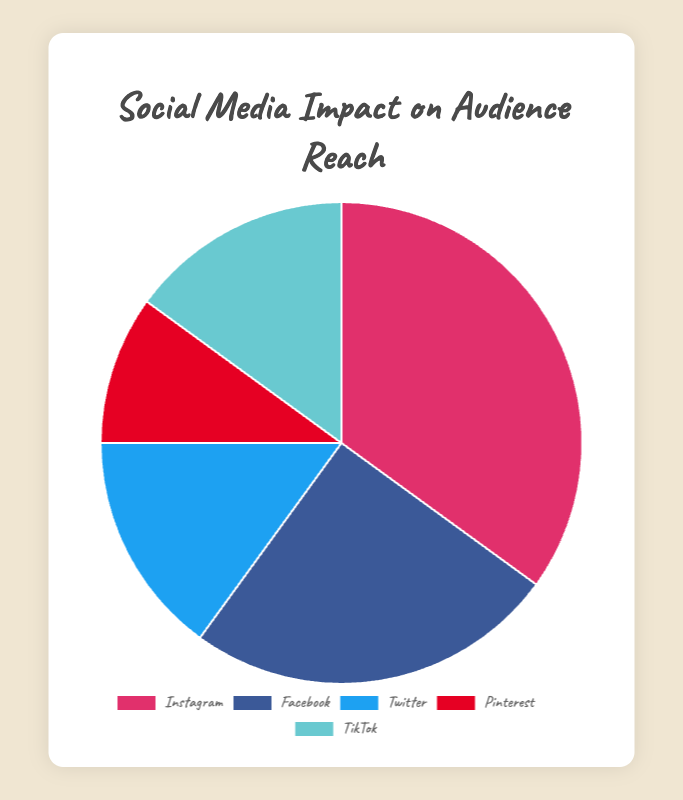What platform holds the largest audience reach percentage? Instagram holds the largest audience reach with 35%. This is clear from the pie chart where Instagram has the largest segment.
Answer: Instagram Which two platforms together account for 50% of the audience reach? Facebook and TikTok both contribute 25% (Facebook: 25%, TikTok: 15%) and 15% (15%) respectively. Adding these percentages (25% + 15%) results in exactly 50%.
Answer: Facebook and Twitter Which platform's segment is visually the smallest? Pinterest has the smallest segment of the pie chart, indicating its audience reach percentage is the lowest at 10%.
Answer: Pinterest How much larger is Instagram's audience reach compared to Pinterest's? Instagram's reach is 35% while Pinterest's reach is 10%. The difference can be calculated as 35% - 10% = 25%.
Answer: 25% If you combine Twitter and TikTok, what is their total audience reach percentage? Twitter has a 15% reach and TikTok also has a 15% reach. Adding these (15% + 15%) gives a total audience reach of 30%.
Answer: 30% What percentage of the total audience reach is covered by platforms other than Instagram? Instagram's reach is 35%, so the remaining percentage can be calculated by subtracting Instagram's percentage from 100%. Therefore, 100% - 35% = 65%.
Answer: 65% Which two platforms have equal audience reach percentages? Twitter and TikTok both have an audience reach of 15%. This is visually clear from the pie chart segments being equal in size and values indicated.
Answer: Twitter and TikTok What is the combined percentage of audience reach for platforms traditionally considered visual-centric (Instagram and Pinterest)? Instagram provides 35% and Pinterest provides 10%. Combining these, 35% + 10% = 45%.
Answer: 45% Considering all the platforms, what is the average audience reach percentage? The sum of all platforms' audience reach percentages is 100% (35 + 25 + 15 + 10 + 15). With 5 platforms, the average can be calculated as 100% / 5 = 20%.
Answer: 20% 